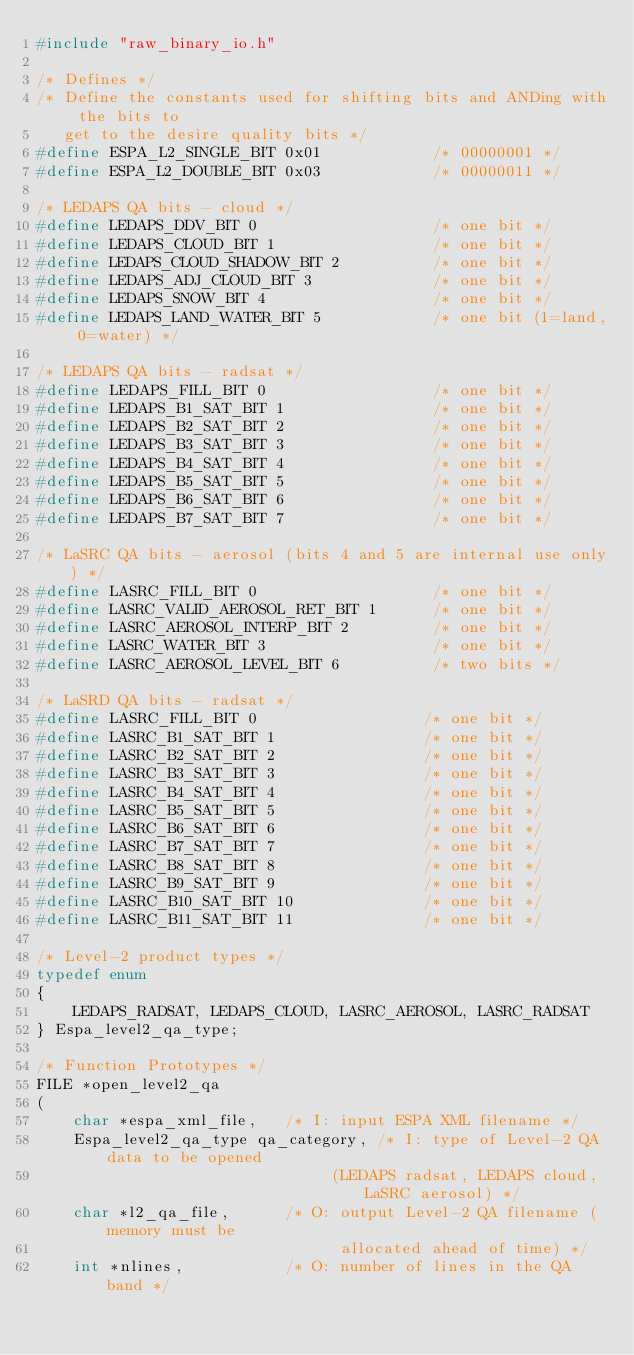<code> <loc_0><loc_0><loc_500><loc_500><_C_>#include "raw_binary_io.h"

/* Defines */
/* Define the constants used for shifting bits and ANDing with the bits to
   get to the desire quality bits */
#define ESPA_L2_SINGLE_BIT 0x01            /* 00000001 */
#define ESPA_L2_DOUBLE_BIT 0x03            /* 00000011 */

/* LEDAPS QA bits - cloud */
#define LEDAPS_DDV_BIT 0                   /* one bit */
#define LEDAPS_CLOUD_BIT 1                 /* one bit */
#define LEDAPS_CLOUD_SHADOW_BIT 2          /* one bit */
#define LEDAPS_ADJ_CLOUD_BIT 3             /* one bit */
#define LEDAPS_SNOW_BIT 4                  /* one bit */
#define LEDAPS_LAND_WATER_BIT 5            /* one bit (1=land, 0=water) */

/* LEDAPS QA bits - radsat */
#define LEDAPS_FILL_BIT 0                  /* one bit */
#define LEDAPS_B1_SAT_BIT 1                /* one bit */
#define LEDAPS_B2_SAT_BIT 2                /* one bit */
#define LEDAPS_B3_SAT_BIT 3                /* one bit */
#define LEDAPS_B4_SAT_BIT 4                /* one bit */
#define LEDAPS_B5_SAT_BIT 5                /* one bit */
#define LEDAPS_B6_SAT_BIT 6                /* one bit */
#define LEDAPS_B7_SAT_BIT 7                /* one bit */

/* LaSRC QA bits - aerosol (bits 4 and 5 are internal use only) */
#define LASRC_FILL_BIT 0                   /* one bit */
#define LASRC_VALID_AEROSOL_RET_BIT 1      /* one bit */
#define LASRC_AEROSOL_INTERP_BIT 2         /* one bit */
#define LASRC_WATER_BIT 3                  /* one bit */
#define LASRC_AEROSOL_LEVEL_BIT 6          /* two bits */

/* LaSRD QA bits - radsat */
#define LASRC_FILL_BIT 0                  /* one bit */
#define LASRC_B1_SAT_BIT 1                /* one bit */
#define LASRC_B2_SAT_BIT 2                /* one bit */
#define LASRC_B3_SAT_BIT 3                /* one bit */
#define LASRC_B4_SAT_BIT 4                /* one bit */
#define LASRC_B5_SAT_BIT 5                /* one bit */
#define LASRC_B6_SAT_BIT 6                /* one bit */
#define LASRC_B7_SAT_BIT 7                /* one bit */
#define LASRC_B8_SAT_BIT 8                /* one bit */
#define LASRC_B9_SAT_BIT 9                /* one bit */
#define LASRC_B10_SAT_BIT 10              /* one bit */
#define LASRC_B11_SAT_BIT 11              /* one bit */

/* Level-2 product types */
typedef enum
{
    LEDAPS_RADSAT, LEDAPS_CLOUD, LASRC_AEROSOL, LASRC_RADSAT
} Espa_level2_qa_type;

/* Function Prototypes */
FILE *open_level2_qa
(
    char *espa_xml_file,   /* I: input ESPA XML filename */
    Espa_level2_qa_type qa_category, /* I: type of Level-2 QA data to be opened
                                (LEDAPS radsat, LEDAPS cloud, LaSRC aerosol) */
    char *l2_qa_file,      /* O: output Level-2 QA filename (memory must be
                                 allocated ahead of time) */
    int *nlines,           /* O: number of lines in the QA band */</code> 